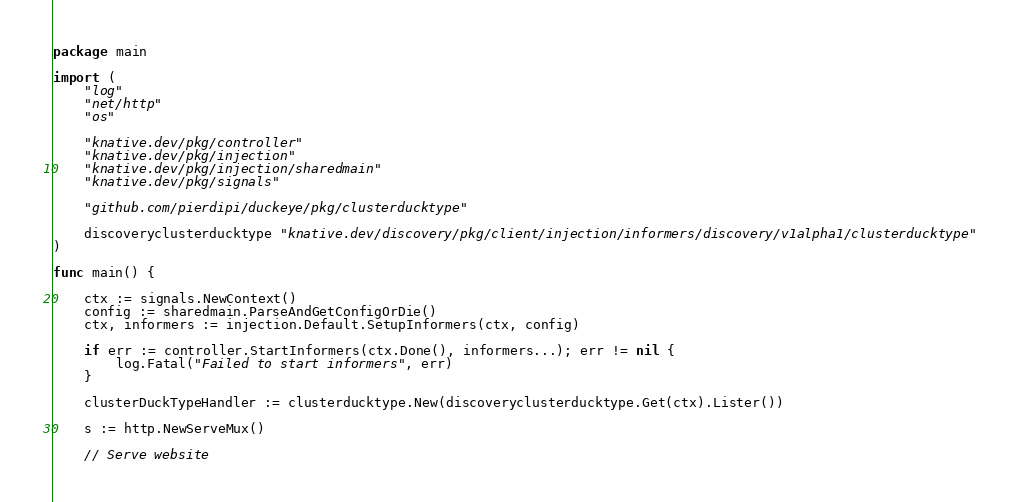<code> <loc_0><loc_0><loc_500><loc_500><_Go_>package main

import (
	"log"
	"net/http"
	"os"

	"knative.dev/pkg/controller"
	"knative.dev/pkg/injection"
	"knative.dev/pkg/injection/sharedmain"
	"knative.dev/pkg/signals"

	"github.com/pierdipi/duckeye/pkg/clusterducktype"

	discoveryclusterducktype "knative.dev/discovery/pkg/client/injection/informers/discovery/v1alpha1/clusterducktype"
)

func main() {

	ctx := signals.NewContext()
	config := sharedmain.ParseAndGetConfigOrDie()
	ctx, informers := injection.Default.SetupInformers(ctx, config)

	if err := controller.StartInformers(ctx.Done(), informers...); err != nil {
		log.Fatal("Failed to start informers", err)
	}

	clusterDuckTypeHandler := clusterducktype.New(discoveryclusterducktype.Get(ctx).Lister())

	s := http.NewServeMux()

	// Serve website</code> 